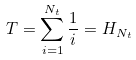<formula> <loc_0><loc_0><loc_500><loc_500>T = \sum _ { i = 1 } ^ { N _ { t } } \frac { 1 } { i } = H _ { N _ { t } }</formula> 